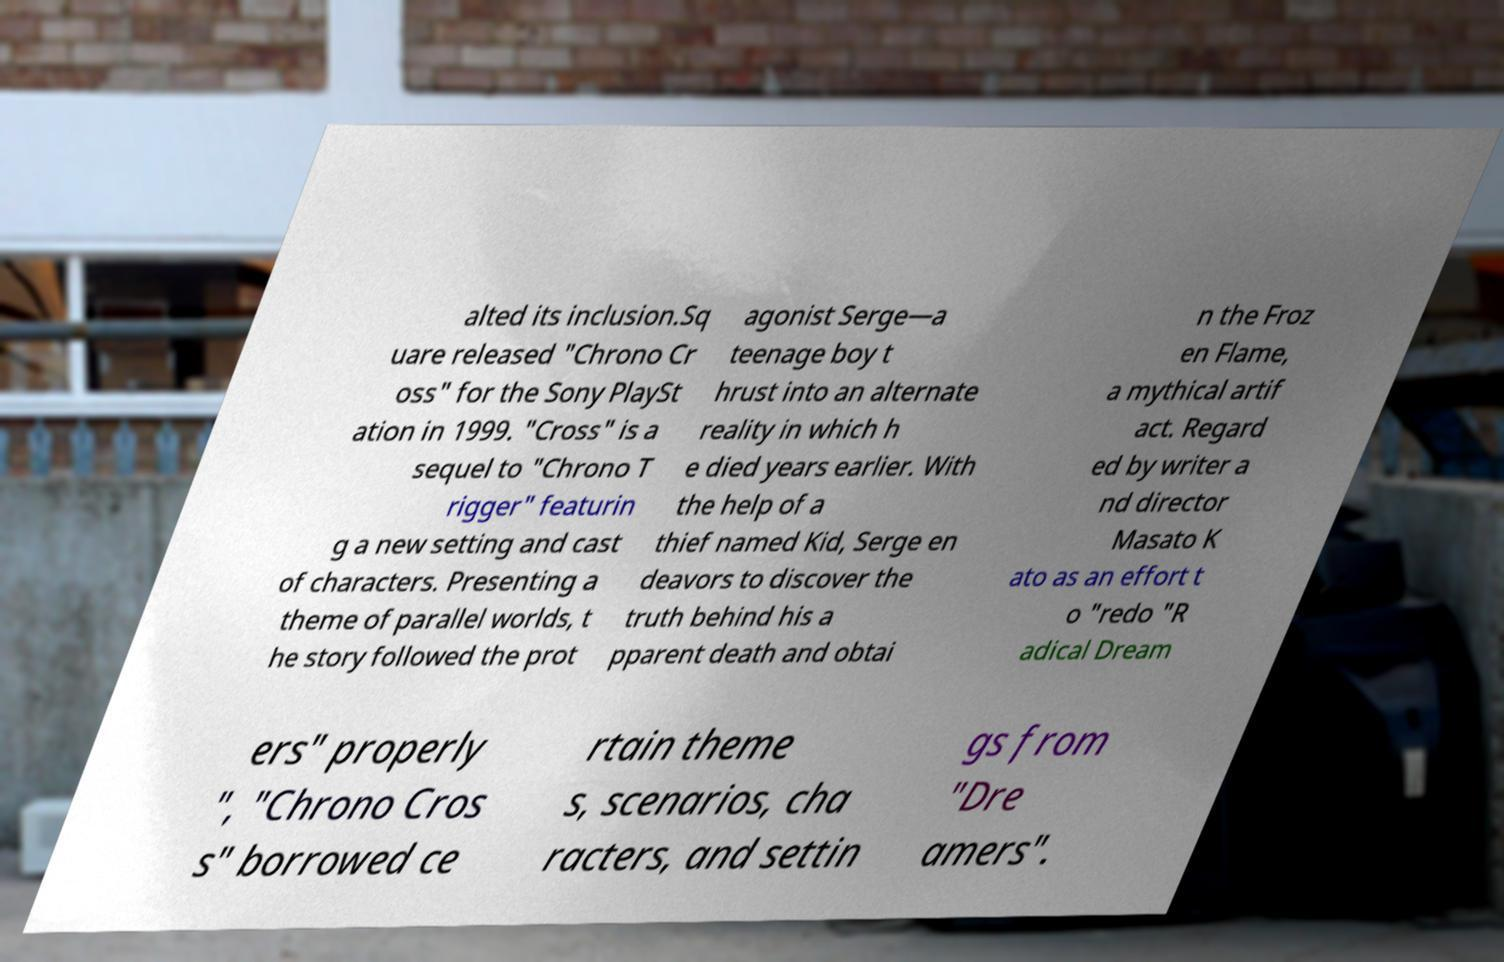Could you extract and type out the text from this image? alted its inclusion.Sq uare released "Chrono Cr oss" for the Sony PlaySt ation in 1999. "Cross" is a sequel to "Chrono T rigger" featurin g a new setting and cast of characters. Presenting a theme of parallel worlds, t he story followed the prot agonist Serge—a teenage boy t hrust into an alternate reality in which h e died years earlier. With the help of a thief named Kid, Serge en deavors to discover the truth behind his a pparent death and obtai n the Froz en Flame, a mythical artif act. Regard ed by writer a nd director Masato K ato as an effort t o "redo "R adical Dream ers" properly ", "Chrono Cros s" borrowed ce rtain theme s, scenarios, cha racters, and settin gs from "Dre amers". 